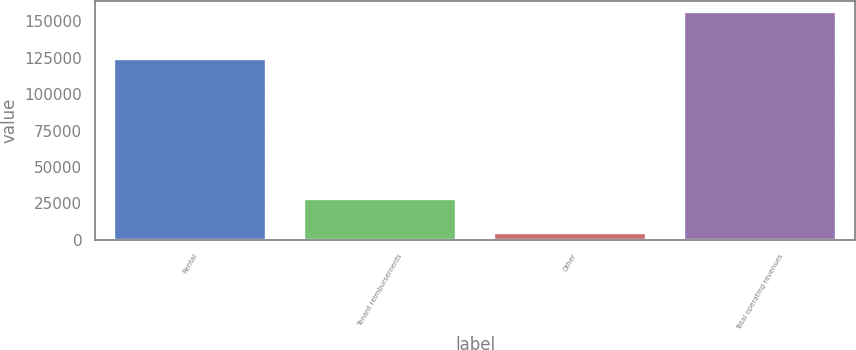Convert chart to OTSL. <chart><loc_0><loc_0><loc_500><loc_500><bar_chart><fcel>Rental<fcel>Tenant reimbursements<fcel>Other<fcel>Total operating revenues<nl><fcel>123860<fcel>27981<fcel>4434<fcel>156275<nl></chart> 